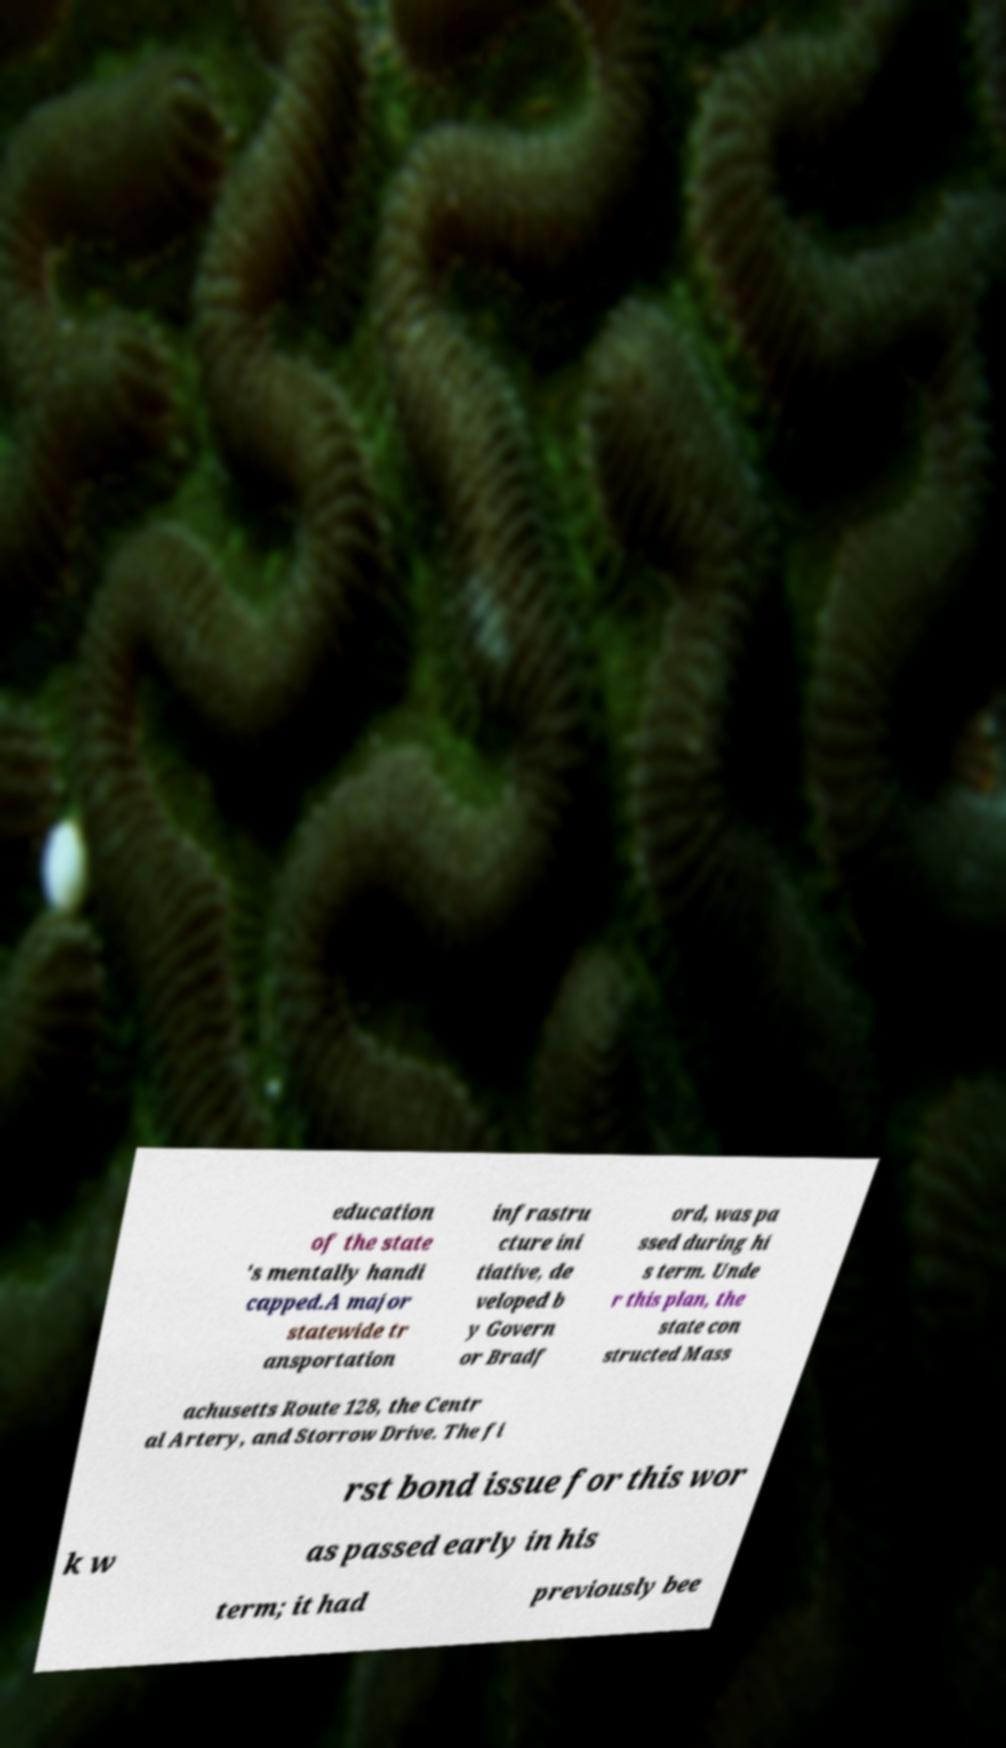Can you accurately transcribe the text from the provided image for me? education of the state 's mentally handi capped.A major statewide tr ansportation infrastru cture ini tiative, de veloped b y Govern or Bradf ord, was pa ssed during hi s term. Unde r this plan, the state con structed Mass achusetts Route 128, the Centr al Artery, and Storrow Drive. The fi rst bond issue for this wor k w as passed early in his term; it had previously bee 